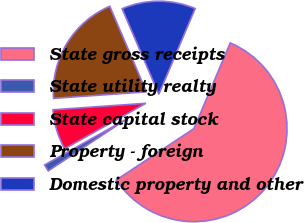<chart> <loc_0><loc_0><loc_500><loc_500><pie_chart><fcel>State gross receipts<fcel>State utility realty<fcel>State capital stock<fcel>Property - foreign<fcel>Domestic property and other<nl><fcel>59.31%<fcel>1.19%<fcel>7.0%<fcel>19.67%<fcel>12.82%<nl></chart> 